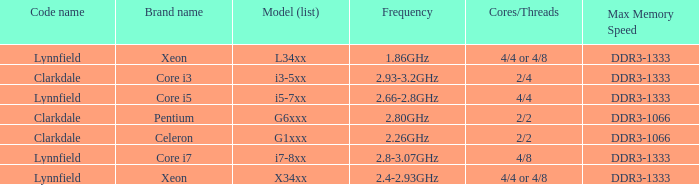What brand is model I7-8xx? Core i7. 